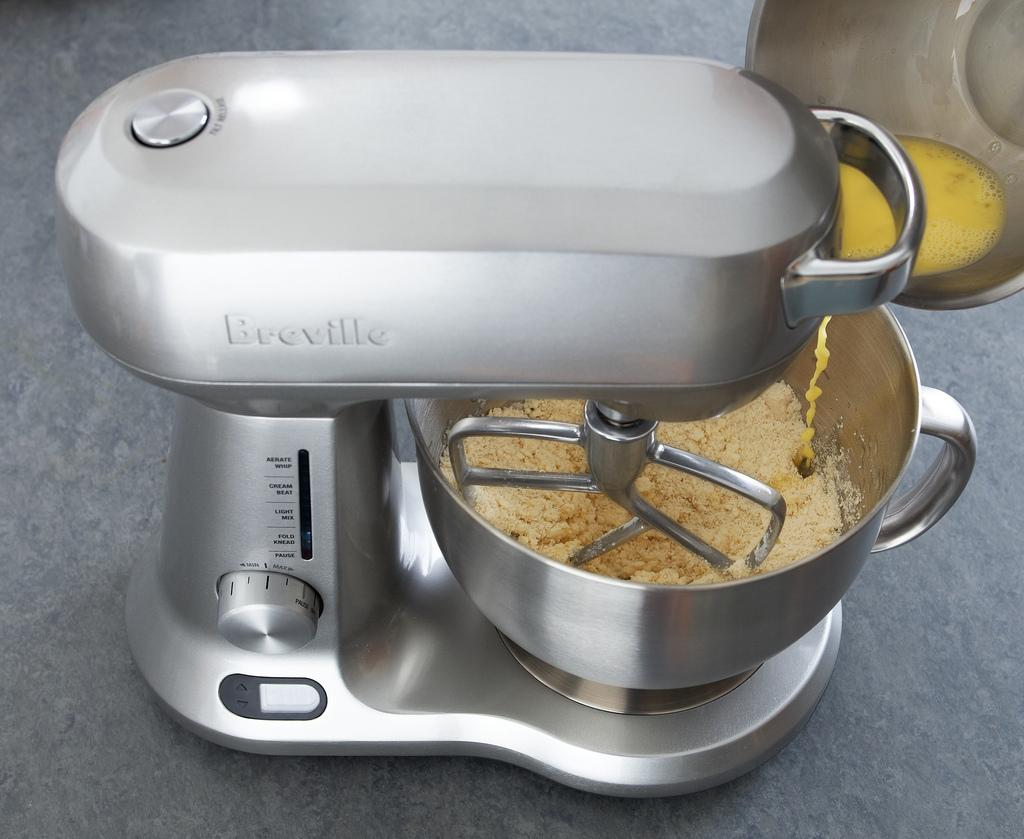Provide a one-sentence caption for the provided image. a Breville stand mixer in silver with settings that include Fold Mix, Cream Beat, Pause, Light Mix, and Aerate Whip. 